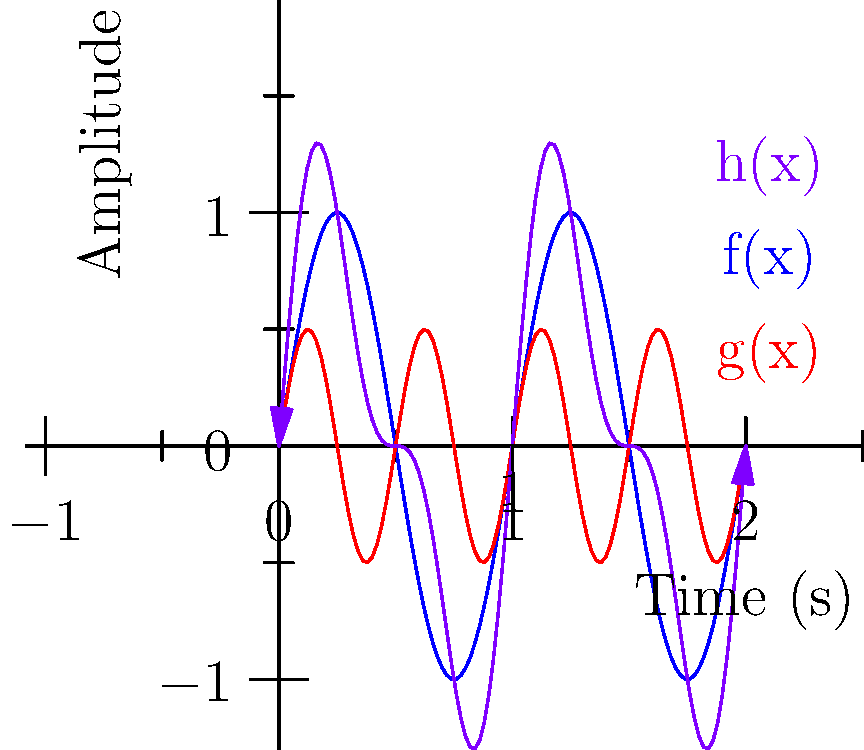Given the waveform $h(x) = \sin(2\pi x) + 0.5\sin(4\pi x)$ representing a retro-style background music track, where $x$ is time in seconds, at what time point should the loop be placed to ensure seamless looping? Assume the track needs to loop every second. To find the optimal loop point for seamless background music, we need to consider the following steps:

1) The function $h(x)$ is composed of two periodic functions:
   $f(x) = \sin(2\pi x)$ (period = 1 second)
   $g(x) = 0.5\sin(4\pi x)$ (period = 0.5 seconds)

2) For seamless looping, we need to find a point where:
   $h(0) = h(1)$
   $h'(0) = h'(1)$

3) Given that $\sin$ and $\cos$ have a period of $2\pi$, we know:
   $\sin(2\pi \cdot 0) = \sin(2\pi \cdot 1) = 0$
   $\sin(4\pi \cdot 0) = \sin(4\pi \cdot 1) = 0$

4) Therefore, $h(0) = h(1) = 0$, satisfying our first condition.

5) Now, let's check the derivatives:
   $h'(x) = 2\pi \cos(2\pi x) + 2\pi \cos(4\pi x)$

6) At $x = 0$ and $x = 1$:
   $h'(0) = h'(1) = 2\pi + 2\pi = 4\pi$

7) This satisfies our second condition for seamless looping.

8) The graph shows that at $x = 0$ and $x = 1$, the waveform passes through zero with the same slope, confirming our calculations visually.

Therefore, placing the loop point at either 0 or 1 second will ensure seamless looping of the track every second.
Answer: 0 or 1 second 